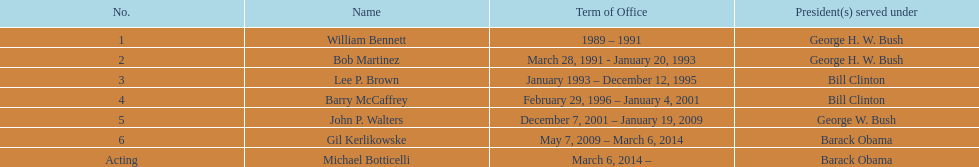Who were the members of barack obama's team? Gil Kerlikowske. 